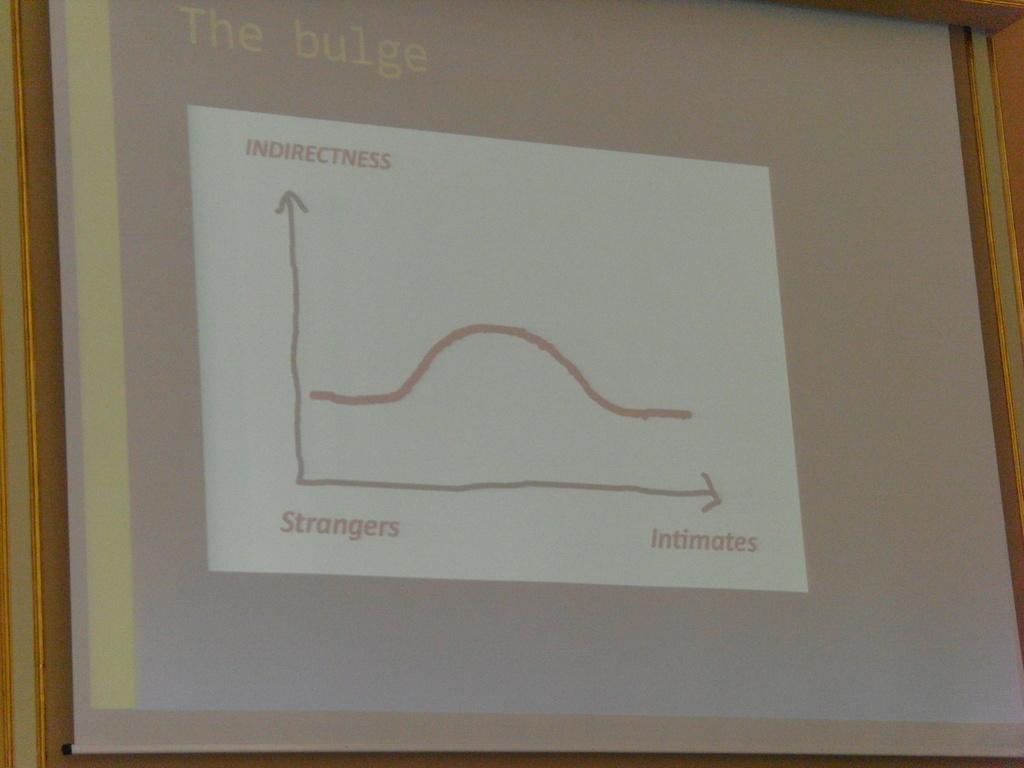What is written at the bottom of the graph, on the left side?
Provide a short and direct response. Strangers. What is this graph for?
Your answer should be compact. The bulge. 